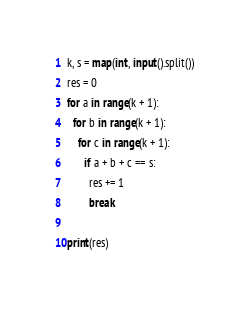<code> <loc_0><loc_0><loc_500><loc_500><_Python_>k, s = map(int, input().split())
res = 0
for a in range(k + 1):
  for b in range(k + 1):
    for c in range(k + 1):
      if a + b + c == s:
        res += 1
        break
        
print(res)</code> 